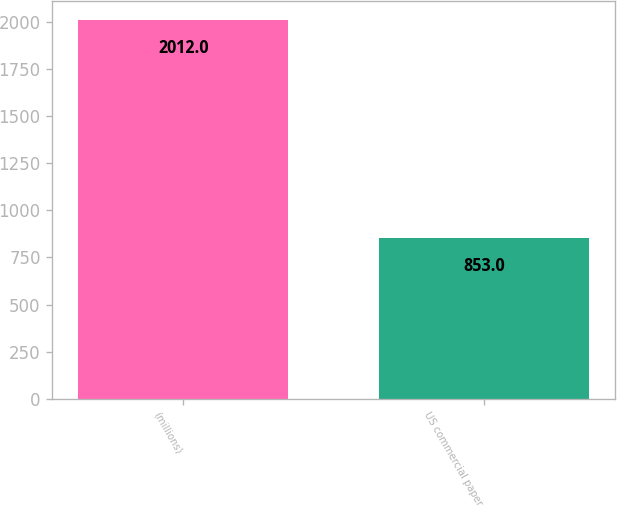<chart> <loc_0><loc_0><loc_500><loc_500><bar_chart><fcel>(millions)<fcel>US commercial paper<nl><fcel>2012<fcel>853<nl></chart> 